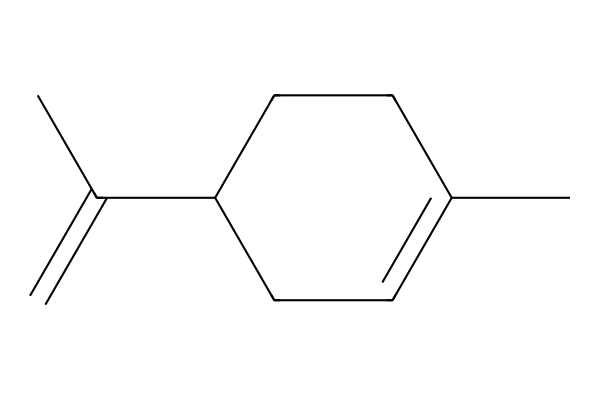What is the molecular formula of limonene? To deduce the molecular formula from the SMILES representation, count the carbon (C) and hydrogen (H) atoms indicated. The structure has 10 carbon atoms and 16 hydrogen atoms, resulting in the molecular formula C10H16.
Answer: C10H16 How many rings are present in limonene? The SMILES shows a structure formed by a cycloalkane, which includes one cyclic portion indicated by the "C1" and the closing bond that links back to the first carbon. Thus, it contains one ring.
Answer: 1 What type of compound is limonene? Limonene is classified as a terpene because of its specific arrangement of carbon and hydrogen atoms, which are typically seen in compounds derived from plants, especially terpenoids.
Answer: terpene What is the degree of unsaturation in limonene? To find the degree of unsaturation, use the formula U = (2C + 2 - H)/2. Here, with C=10 and H=16, the calculation results in U = 2, indicating two degrees of unsaturation.
Answer: 2 Does limonene contain any functional groups? Limonene mainly consists of a cyclic structure and does not contain functional groups like -OH or -COOH that denote alcohols or carboxylic acids, thus it mainly suggests aliphatic characteristics.
Answer: no 